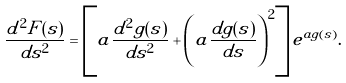Convert formula to latex. <formula><loc_0><loc_0><loc_500><loc_500>\frac { d ^ { 2 } F ( s ) } { d s ^ { 2 } } = \left [ a \frac { d ^ { 2 } g ( s ) } { d s ^ { 2 } } + \left ( a \frac { d g ( s ) } { d s } \right ) ^ { 2 } \right ] e ^ { a g ( s ) } .</formula> 